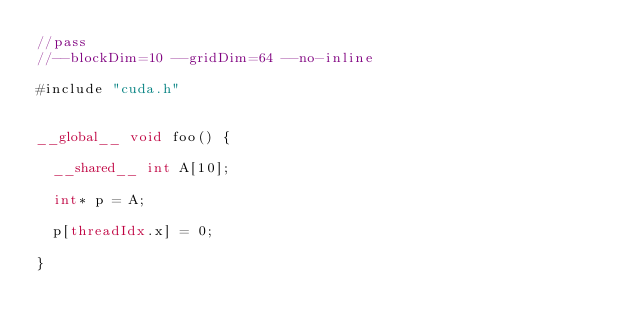Convert code to text. <code><loc_0><loc_0><loc_500><loc_500><_Cuda_>//pass
//--blockDim=10 --gridDim=64 --no-inline

#include "cuda.h"


__global__ void foo() {

  __shared__ int A[10];

  int* p = A;

  p[threadIdx.x] = 0;

}
</code> 